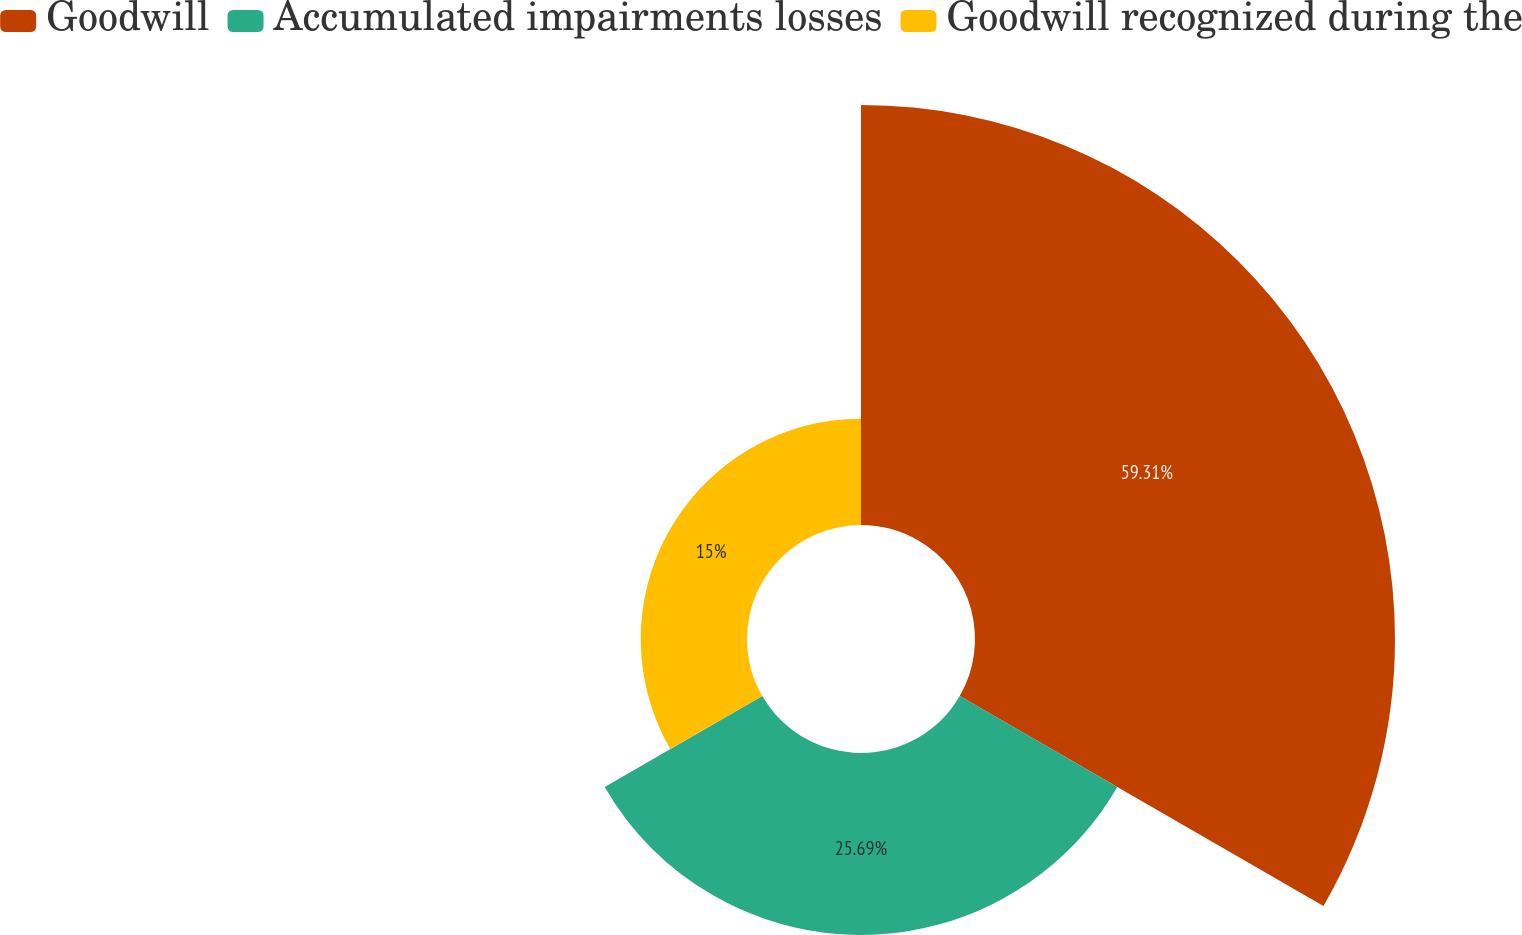Convert chart to OTSL. <chart><loc_0><loc_0><loc_500><loc_500><pie_chart><fcel>Goodwill<fcel>Accumulated impairments losses<fcel>Goodwill recognized during the<nl><fcel>59.3%<fcel>25.69%<fcel>15.0%<nl></chart> 